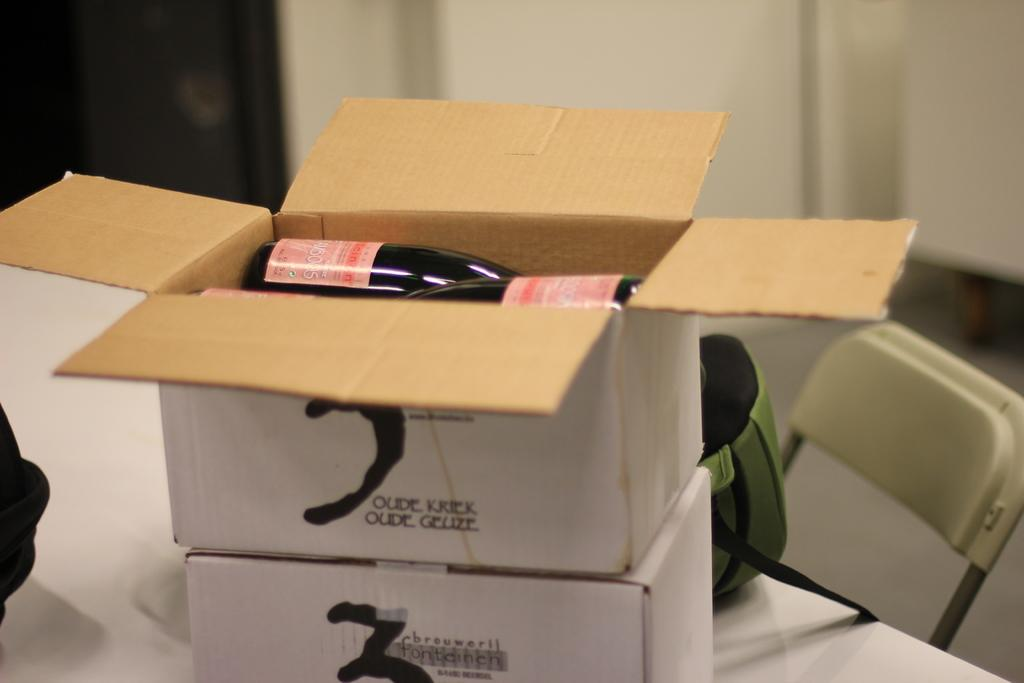<image>
Give a short and clear explanation of the subsequent image. The number 3 can be seen in black on a white box 